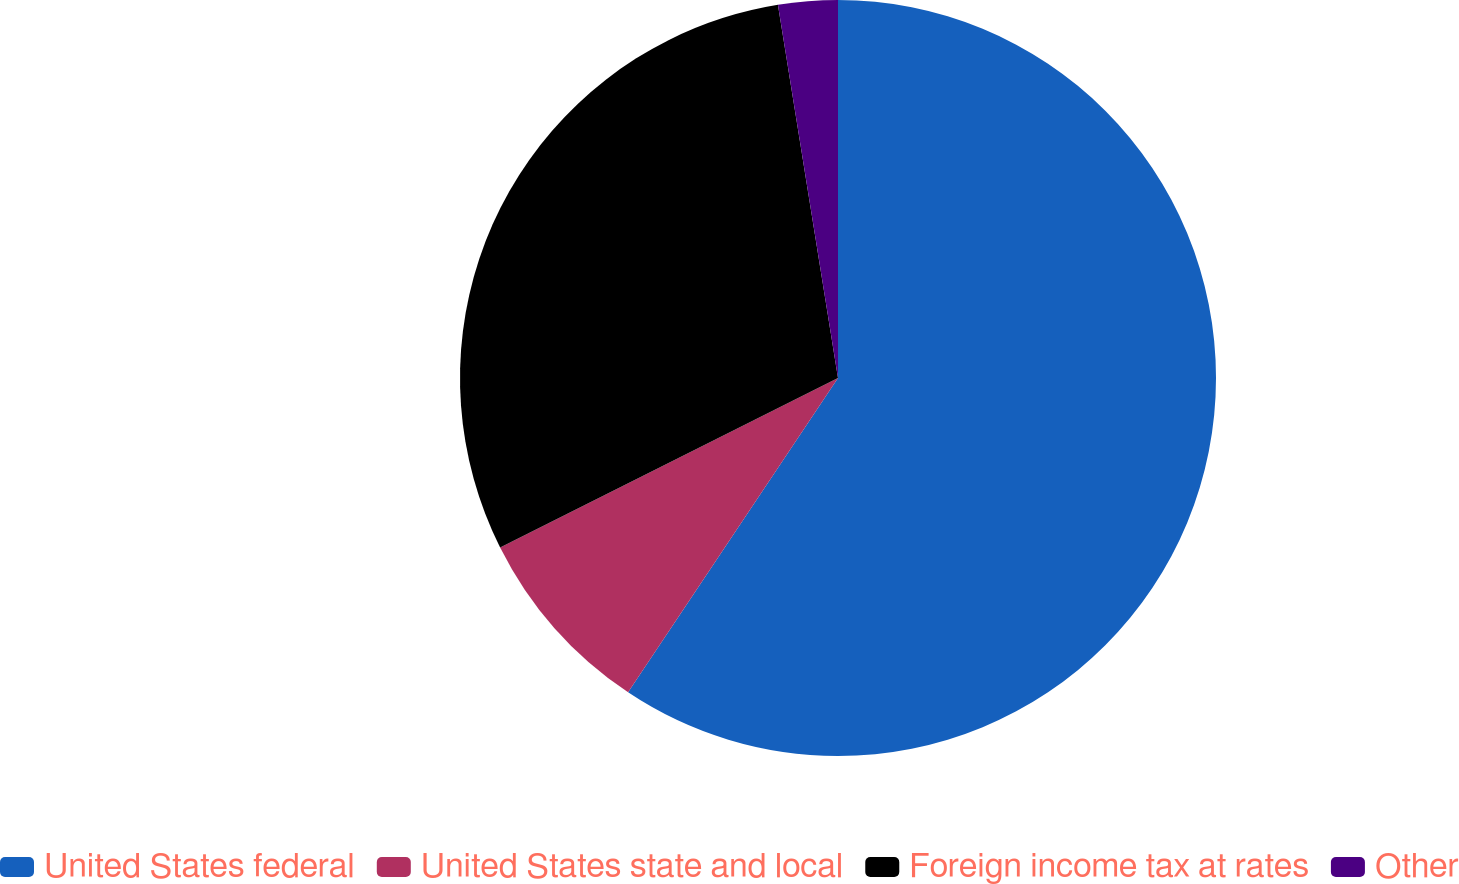Convert chart. <chart><loc_0><loc_0><loc_500><loc_500><pie_chart><fcel>United States federal<fcel>United States state and local<fcel>Foreign income tax at rates<fcel>Other<nl><fcel>59.37%<fcel>8.23%<fcel>29.86%<fcel>2.54%<nl></chart> 